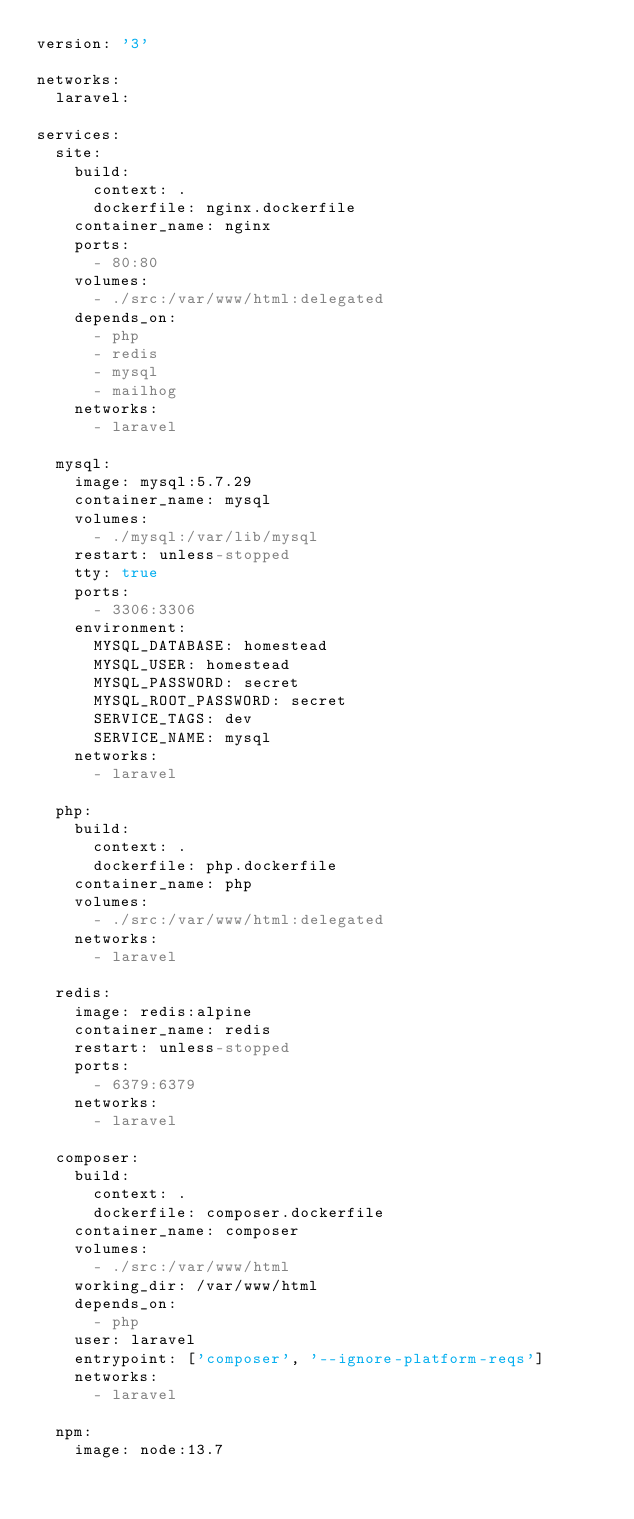<code> <loc_0><loc_0><loc_500><loc_500><_YAML_>version: '3'

networks:
  laravel:

services:
  site:
    build:
      context: .
      dockerfile: nginx.dockerfile
    container_name: nginx
    ports:
      - 80:80
    volumes:
      - ./src:/var/www/html:delegated
    depends_on:
      - php
      - redis
      - mysql
      - mailhog
    networks:
      - laravel

  mysql:
    image: mysql:5.7.29
    container_name: mysql
    volumes:
      - ./mysql:/var/lib/mysql
    restart: unless-stopped
    tty: true
    ports:
      - 3306:3306
    environment:
      MYSQL_DATABASE: homestead
      MYSQL_USER: homestead
      MYSQL_PASSWORD: secret
      MYSQL_ROOT_PASSWORD: secret
      SERVICE_TAGS: dev
      SERVICE_NAME: mysql
    networks:
      - laravel

  php:
    build:
      context: .
      dockerfile: php.dockerfile
    container_name: php
    volumes:
      - ./src:/var/www/html:delegated
    networks:
      - laravel

  redis:
    image: redis:alpine
    container_name: redis
    restart: unless-stopped
    ports:
      - 6379:6379
    networks:
      - laravel

  composer:
    build:
      context: .
      dockerfile: composer.dockerfile
    container_name: composer
    volumes:
      - ./src:/var/www/html
    working_dir: /var/www/html
    depends_on:
      - php
    user: laravel
    entrypoint: ['composer', '--ignore-platform-reqs']
    networks:
      - laravel

  npm:
    image: node:13.7</code> 